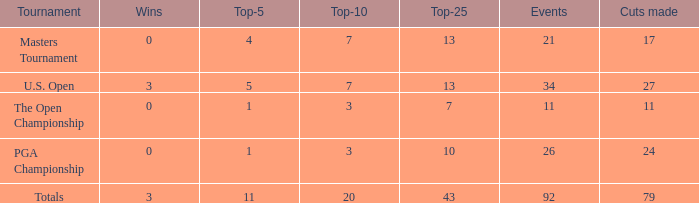I'm looking to parse the entire table for insights. Could you assist me with that? {'header': ['Tournament', 'Wins', 'Top-5', 'Top-10', 'Top-25', 'Events', 'Cuts made'], 'rows': [['Masters Tournament', '0', '4', '7', '13', '21', '17'], ['U.S. Open', '3', '5', '7', '13', '34', '27'], ['The Open Championship', '0', '1', '3', '7', '11', '11'], ['PGA Championship', '0', '1', '3', '10', '26', '24'], ['Totals', '3', '11', '20', '43', '92', '79']]} Name the average cuts for top-25 more than 13 and top-5 less than 11 None. 